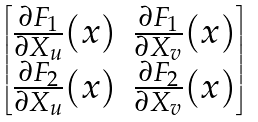<formula> <loc_0><loc_0><loc_500><loc_500>\begin{bmatrix} \frac { \partial F _ { 1 } } { \partial X _ { u } } ( x ) & \frac { \partial F _ { 1 } } { \partial X _ { v } } ( x ) \\ \frac { \partial F _ { 2 } } { \partial X _ { u } } ( x ) & \frac { \partial F _ { 2 } } { \partial X _ { v } } ( x ) \end{bmatrix}</formula> 